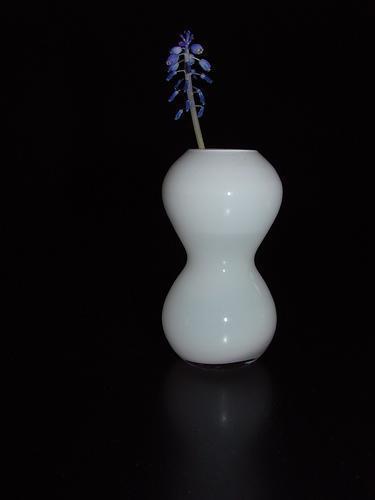How many lilacs are in the vase?
Give a very brief answer. 1. How many vases are there?
Give a very brief answer. 1. How many different vases are there?
Give a very brief answer. 1. How many items are in this photo?
Give a very brief answer. 2. How many purple flowers are in there?
Give a very brief answer. 1. How many vases are there?
Give a very brief answer. 1. How many cars are in the image?
Give a very brief answer. 0. 